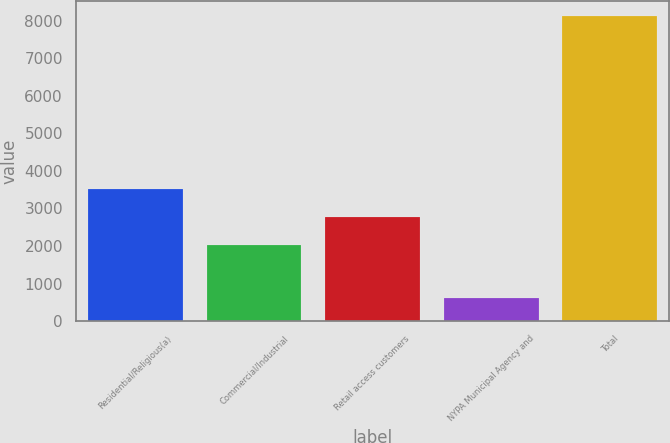<chart> <loc_0><loc_0><loc_500><loc_500><bar_chart><fcel>Residential/Religious(a)<fcel>Commercial/Industrial<fcel>Retail access customers<fcel>NYPA Municipal Agency and<fcel>Total<nl><fcel>3516.2<fcel>2013<fcel>2764.6<fcel>615<fcel>8131<nl></chart> 